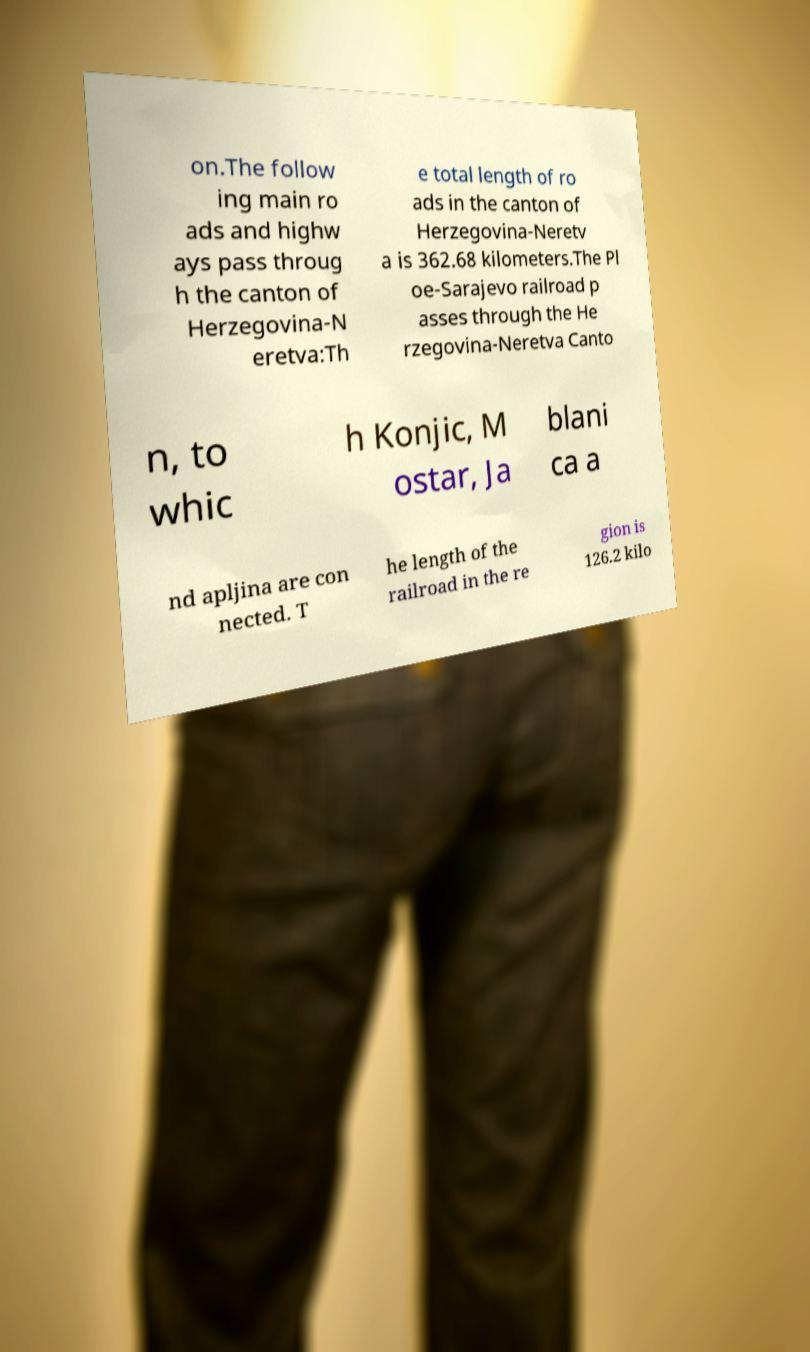Could you extract and type out the text from this image? on.The follow ing main ro ads and highw ays pass throug h the canton of Herzegovina-N eretva:Th e total length of ro ads in the canton of Herzegovina-Neretv a is 362.68 kilometers.The Pl oe-Sarajevo railroad p asses through the He rzegovina-Neretva Canto n, to whic h Konjic, M ostar, Ja blani ca a nd apljina are con nected. T he length of the railroad in the re gion is 126.2 kilo 